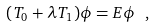<formula> <loc_0><loc_0><loc_500><loc_500>( T _ { 0 } + \lambda T _ { 1 } ) \phi = E \phi \ ,</formula> 